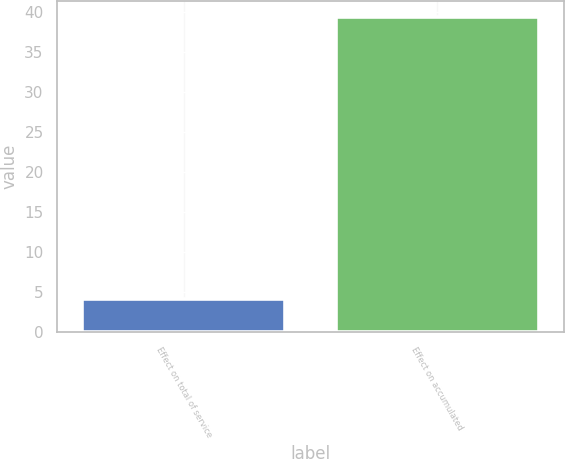<chart> <loc_0><loc_0><loc_500><loc_500><bar_chart><fcel>Effect on total of service<fcel>Effect on accumulated<nl><fcel>4.2<fcel>39.4<nl></chart> 